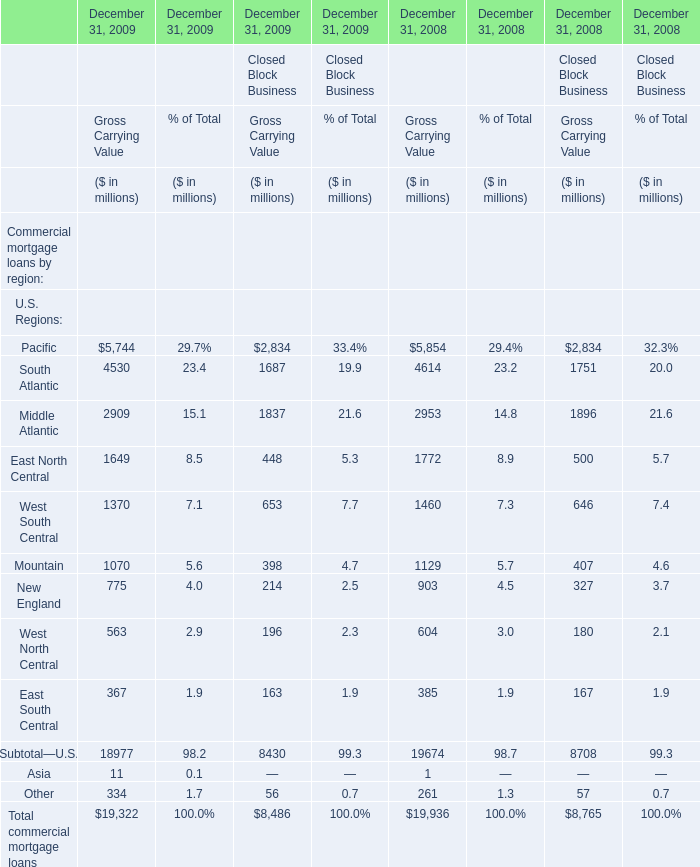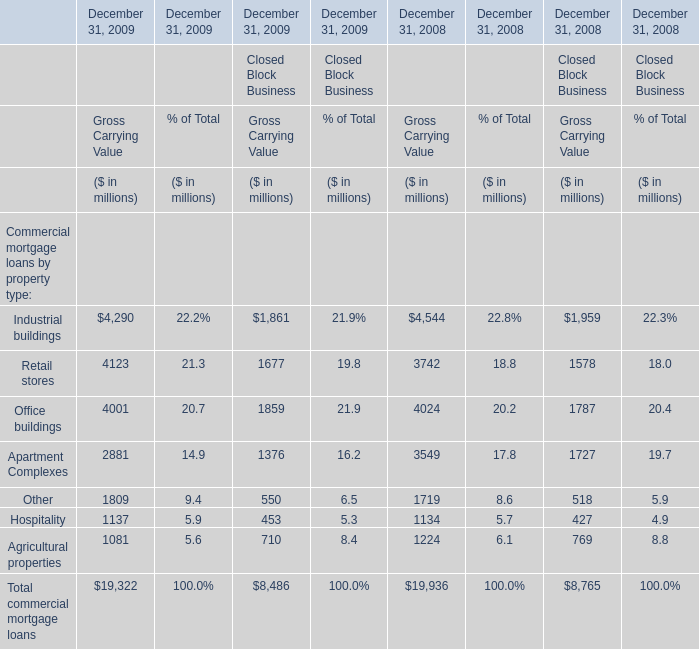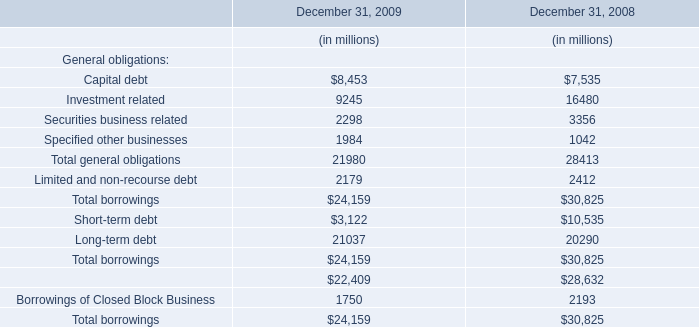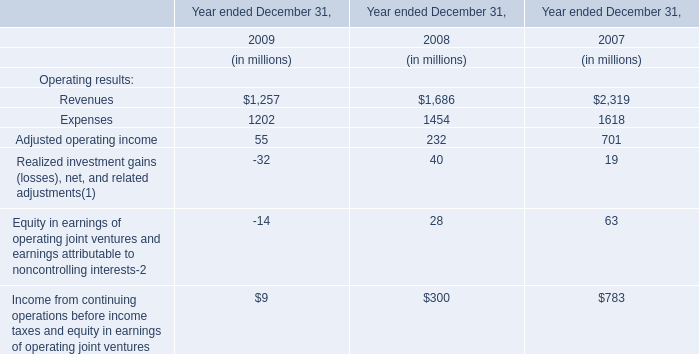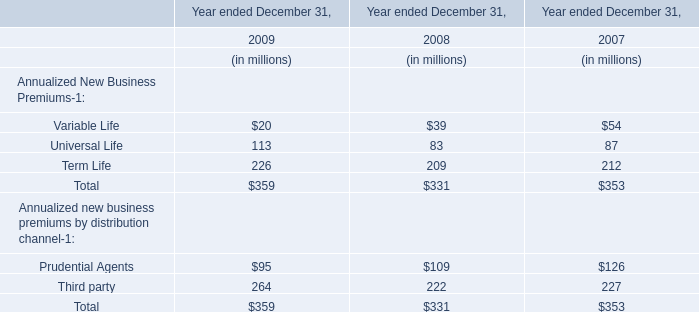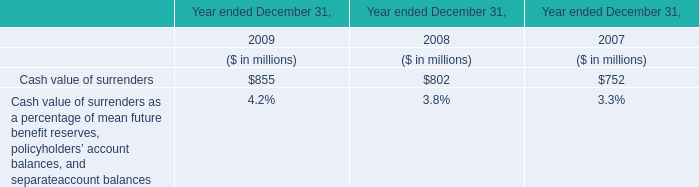What is the sum of the Office buildings for Gross Carrying Value in the years where Industrial buildings is greater than 1 (in million) 
Computations: (((4001 + 1859) + 4024) + 1787)
Answer: 11671.0. 